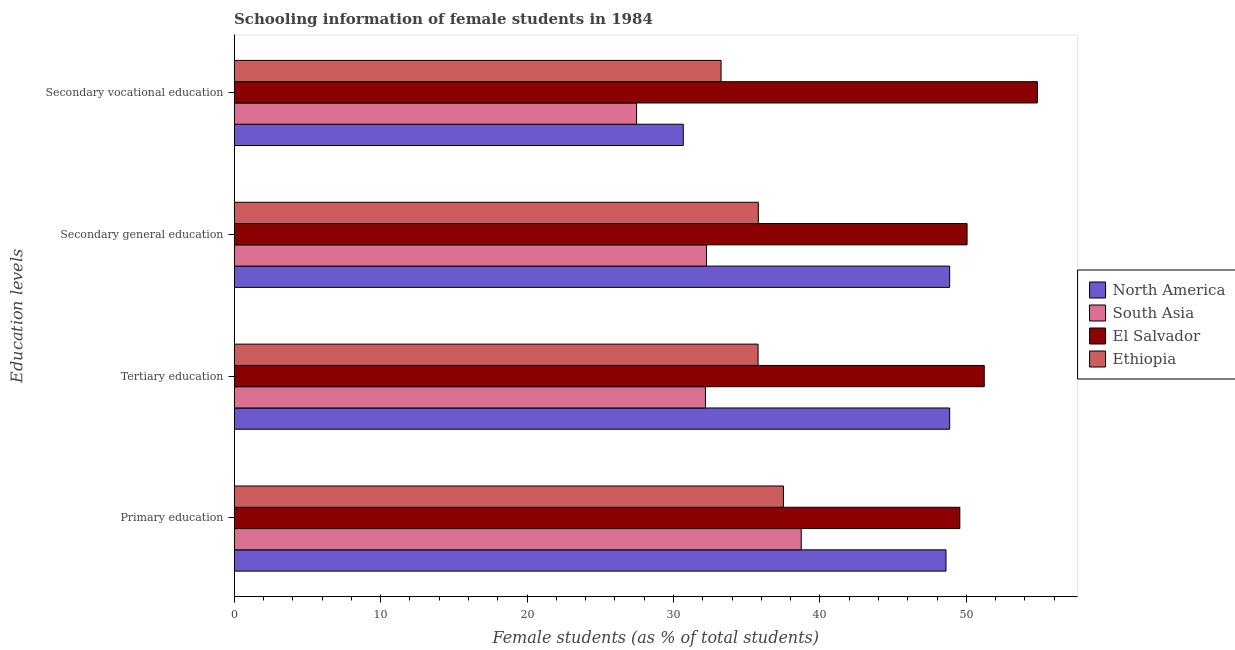How many different coloured bars are there?
Provide a succinct answer. 4. How many groups of bars are there?
Keep it short and to the point. 4. Are the number of bars on each tick of the Y-axis equal?
Your answer should be very brief. Yes. How many bars are there on the 1st tick from the top?
Offer a terse response. 4. What is the label of the 1st group of bars from the top?
Offer a very short reply. Secondary vocational education. What is the percentage of female students in primary education in South Asia?
Your answer should be compact. 38.72. Across all countries, what is the maximum percentage of female students in primary education?
Offer a terse response. 49.55. Across all countries, what is the minimum percentage of female students in primary education?
Your answer should be very brief. 37.51. In which country was the percentage of female students in secondary vocational education maximum?
Your response must be concise. El Salvador. In which country was the percentage of female students in tertiary education minimum?
Make the answer very short. South Asia. What is the total percentage of female students in tertiary education in the graph?
Provide a succinct answer. 168.04. What is the difference between the percentage of female students in tertiary education in Ethiopia and that in El Salvador?
Keep it short and to the point. -15.45. What is the difference between the percentage of female students in secondary education in Ethiopia and the percentage of female students in secondary vocational education in North America?
Keep it short and to the point. 5.12. What is the average percentage of female students in secondary vocational education per country?
Your answer should be compact. 36.56. What is the difference between the percentage of female students in secondary vocational education and percentage of female students in tertiary education in Ethiopia?
Your answer should be compact. -2.53. What is the ratio of the percentage of female students in secondary vocational education in Ethiopia to that in South Asia?
Your response must be concise. 1.21. Is the percentage of female students in primary education in North America less than that in El Salvador?
Offer a terse response. Yes. Is the difference between the percentage of female students in secondary education in El Salvador and South Asia greater than the difference between the percentage of female students in tertiary education in El Salvador and South Asia?
Give a very brief answer. No. What is the difference between the highest and the second highest percentage of female students in secondary education?
Your answer should be compact. 1.19. What is the difference between the highest and the lowest percentage of female students in primary education?
Your answer should be compact. 12.05. In how many countries, is the percentage of female students in secondary education greater than the average percentage of female students in secondary education taken over all countries?
Offer a very short reply. 2. Is the sum of the percentage of female students in secondary vocational education in North America and Ethiopia greater than the maximum percentage of female students in secondary education across all countries?
Provide a succinct answer. Yes. Is it the case that in every country, the sum of the percentage of female students in secondary vocational education and percentage of female students in secondary education is greater than the sum of percentage of female students in primary education and percentage of female students in tertiary education?
Provide a succinct answer. No. What does the 2nd bar from the bottom in Primary education represents?
Make the answer very short. South Asia. How many bars are there?
Offer a very short reply. 16. Are all the bars in the graph horizontal?
Provide a short and direct response. Yes. Does the graph contain grids?
Your response must be concise. No. Where does the legend appear in the graph?
Offer a terse response. Center right. How many legend labels are there?
Keep it short and to the point. 4. What is the title of the graph?
Give a very brief answer. Schooling information of female students in 1984. Does "Ireland" appear as one of the legend labels in the graph?
Your answer should be compact. No. What is the label or title of the X-axis?
Offer a terse response. Female students (as % of total students). What is the label or title of the Y-axis?
Give a very brief answer. Education levels. What is the Female students (as % of total students) in North America in Primary education?
Offer a very short reply. 48.61. What is the Female students (as % of total students) in South Asia in Primary education?
Make the answer very short. 38.72. What is the Female students (as % of total students) in El Salvador in Primary education?
Give a very brief answer. 49.55. What is the Female students (as % of total students) in Ethiopia in Primary education?
Your answer should be compact. 37.51. What is the Female students (as % of total students) of North America in Tertiary education?
Give a very brief answer. 48.86. What is the Female students (as % of total students) of South Asia in Tertiary education?
Provide a succinct answer. 32.18. What is the Female students (as % of total students) of El Salvador in Tertiary education?
Give a very brief answer. 51.22. What is the Female students (as % of total students) in Ethiopia in Tertiary education?
Ensure brevity in your answer.  35.78. What is the Female students (as % of total students) of North America in Secondary general education?
Provide a succinct answer. 48.86. What is the Female students (as % of total students) of South Asia in Secondary general education?
Provide a succinct answer. 32.25. What is the Female students (as % of total students) in El Salvador in Secondary general education?
Ensure brevity in your answer.  50.05. What is the Female students (as % of total students) in Ethiopia in Secondary general education?
Your answer should be very brief. 35.79. What is the Female students (as % of total students) in North America in Secondary vocational education?
Give a very brief answer. 30.67. What is the Female students (as % of total students) in South Asia in Secondary vocational education?
Your answer should be very brief. 27.48. What is the Female students (as % of total students) of El Salvador in Secondary vocational education?
Make the answer very short. 54.85. What is the Female students (as % of total students) of Ethiopia in Secondary vocational education?
Make the answer very short. 33.25. Across all Education levels, what is the maximum Female students (as % of total students) of North America?
Your response must be concise. 48.86. Across all Education levels, what is the maximum Female students (as % of total students) of South Asia?
Keep it short and to the point. 38.72. Across all Education levels, what is the maximum Female students (as % of total students) of El Salvador?
Ensure brevity in your answer.  54.85. Across all Education levels, what is the maximum Female students (as % of total students) in Ethiopia?
Your answer should be very brief. 37.51. Across all Education levels, what is the minimum Female students (as % of total students) of North America?
Make the answer very short. 30.67. Across all Education levels, what is the minimum Female students (as % of total students) in South Asia?
Ensure brevity in your answer.  27.48. Across all Education levels, what is the minimum Female students (as % of total students) of El Salvador?
Keep it short and to the point. 49.55. Across all Education levels, what is the minimum Female students (as % of total students) in Ethiopia?
Offer a very short reply. 33.25. What is the total Female students (as % of total students) of North America in the graph?
Your answer should be very brief. 176.99. What is the total Female students (as % of total students) of South Asia in the graph?
Offer a terse response. 130.64. What is the total Female students (as % of total students) in El Salvador in the graph?
Keep it short and to the point. 205.67. What is the total Female students (as % of total students) of Ethiopia in the graph?
Ensure brevity in your answer.  142.33. What is the difference between the Female students (as % of total students) in North America in Primary education and that in Tertiary education?
Your response must be concise. -0.25. What is the difference between the Female students (as % of total students) in South Asia in Primary education and that in Tertiary education?
Ensure brevity in your answer.  6.54. What is the difference between the Female students (as % of total students) in El Salvador in Primary education and that in Tertiary education?
Ensure brevity in your answer.  -1.67. What is the difference between the Female students (as % of total students) of Ethiopia in Primary education and that in Tertiary education?
Your response must be concise. 1.73. What is the difference between the Female students (as % of total students) of North America in Primary education and that in Secondary general education?
Make the answer very short. -0.25. What is the difference between the Female students (as % of total students) of South Asia in Primary education and that in Secondary general education?
Give a very brief answer. 6.47. What is the difference between the Female students (as % of total students) in El Salvador in Primary education and that in Secondary general education?
Your answer should be very brief. -0.49. What is the difference between the Female students (as % of total students) in Ethiopia in Primary education and that in Secondary general education?
Keep it short and to the point. 1.71. What is the difference between the Female students (as % of total students) in North America in Primary education and that in Secondary vocational education?
Make the answer very short. 17.94. What is the difference between the Female students (as % of total students) of South Asia in Primary education and that in Secondary vocational education?
Offer a terse response. 11.24. What is the difference between the Female students (as % of total students) in El Salvador in Primary education and that in Secondary vocational education?
Your answer should be compact. -5.3. What is the difference between the Female students (as % of total students) in Ethiopia in Primary education and that in Secondary vocational education?
Make the answer very short. 4.26. What is the difference between the Female students (as % of total students) in North America in Tertiary education and that in Secondary general education?
Keep it short and to the point. -0. What is the difference between the Female students (as % of total students) of South Asia in Tertiary education and that in Secondary general education?
Make the answer very short. -0.07. What is the difference between the Female students (as % of total students) of El Salvador in Tertiary education and that in Secondary general education?
Offer a terse response. 1.17. What is the difference between the Female students (as % of total students) in Ethiopia in Tertiary education and that in Secondary general education?
Your answer should be compact. -0.02. What is the difference between the Female students (as % of total students) in North America in Tertiary education and that in Secondary vocational education?
Provide a succinct answer. 18.19. What is the difference between the Female students (as % of total students) of South Asia in Tertiary education and that in Secondary vocational education?
Provide a succinct answer. 4.7. What is the difference between the Female students (as % of total students) in El Salvador in Tertiary education and that in Secondary vocational education?
Make the answer very short. -3.63. What is the difference between the Female students (as % of total students) of Ethiopia in Tertiary education and that in Secondary vocational education?
Your answer should be very brief. 2.53. What is the difference between the Female students (as % of total students) in North America in Secondary general education and that in Secondary vocational education?
Ensure brevity in your answer.  18.19. What is the difference between the Female students (as % of total students) of South Asia in Secondary general education and that in Secondary vocational education?
Make the answer very short. 4.77. What is the difference between the Female students (as % of total students) in El Salvador in Secondary general education and that in Secondary vocational education?
Offer a very short reply. -4.8. What is the difference between the Female students (as % of total students) in Ethiopia in Secondary general education and that in Secondary vocational education?
Your answer should be very brief. 2.54. What is the difference between the Female students (as % of total students) of North America in Primary education and the Female students (as % of total students) of South Asia in Tertiary education?
Offer a terse response. 16.42. What is the difference between the Female students (as % of total students) in North America in Primary education and the Female students (as % of total students) in El Salvador in Tertiary education?
Your response must be concise. -2.62. What is the difference between the Female students (as % of total students) of North America in Primary education and the Female students (as % of total students) of Ethiopia in Tertiary education?
Ensure brevity in your answer.  12.83. What is the difference between the Female students (as % of total students) of South Asia in Primary education and the Female students (as % of total students) of El Salvador in Tertiary education?
Offer a terse response. -12.5. What is the difference between the Female students (as % of total students) in South Asia in Primary education and the Female students (as % of total students) in Ethiopia in Tertiary education?
Your response must be concise. 2.95. What is the difference between the Female students (as % of total students) of El Salvador in Primary education and the Female students (as % of total students) of Ethiopia in Tertiary education?
Make the answer very short. 13.78. What is the difference between the Female students (as % of total students) of North America in Primary education and the Female students (as % of total students) of South Asia in Secondary general education?
Your answer should be compact. 16.35. What is the difference between the Female students (as % of total students) in North America in Primary education and the Female students (as % of total students) in El Salvador in Secondary general education?
Make the answer very short. -1.44. What is the difference between the Female students (as % of total students) of North America in Primary education and the Female students (as % of total students) of Ethiopia in Secondary general education?
Your answer should be compact. 12.81. What is the difference between the Female students (as % of total students) of South Asia in Primary education and the Female students (as % of total students) of El Salvador in Secondary general education?
Make the answer very short. -11.32. What is the difference between the Female students (as % of total students) of South Asia in Primary education and the Female students (as % of total students) of Ethiopia in Secondary general education?
Keep it short and to the point. 2.93. What is the difference between the Female students (as % of total students) in El Salvador in Primary education and the Female students (as % of total students) in Ethiopia in Secondary general education?
Your answer should be very brief. 13.76. What is the difference between the Female students (as % of total students) of North America in Primary education and the Female students (as % of total students) of South Asia in Secondary vocational education?
Ensure brevity in your answer.  21.13. What is the difference between the Female students (as % of total students) in North America in Primary education and the Female students (as % of total students) in El Salvador in Secondary vocational education?
Your response must be concise. -6.24. What is the difference between the Female students (as % of total students) of North America in Primary education and the Female students (as % of total students) of Ethiopia in Secondary vocational education?
Ensure brevity in your answer.  15.36. What is the difference between the Female students (as % of total students) of South Asia in Primary education and the Female students (as % of total students) of El Salvador in Secondary vocational education?
Give a very brief answer. -16.12. What is the difference between the Female students (as % of total students) in South Asia in Primary education and the Female students (as % of total students) in Ethiopia in Secondary vocational education?
Ensure brevity in your answer.  5.47. What is the difference between the Female students (as % of total students) of El Salvador in Primary education and the Female students (as % of total students) of Ethiopia in Secondary vocational education?
Your response must be concise. 16.3. What is the difference between the Female students (as % of total students) in North America in Tertiary education and the Female students (as % of total students) in South Asia in Secondary general education?
Offer a very short reply. 16.61. What is the difference between the Female students (as % of total students) in North America in Tertiary education and the Female students (as % of total students) in El Salvador in Secondary general education?
Your answer should be compact. -1.19. What is the difference between the Female students (as % of total students) in North America in Tertiary education and the Female students (as % of total students) in Ethiopia in Secondary general education?
Ensure brevity in your answer.  13.07. What is the difference between the Female students (as % of total students) of South Asia in Tertiary education and the Female students (as % of total students) of El Salvador in Secondary general education?
Keep it short and to the point. -17.86. What is the difference between the Female students (as % of total students) in South Asia in Tertiary education and the Female students (as % of total students) in Ethiopia in Secondary general education?
Your answer should be very brief. -3.61. What is the difference between the Female students (as % of total students) in El Salvador in Tertiary education and the Female students (as % of total students) in Ethiopia in Secondary general education?
Keep it short and to the point. 15.43. What is the difference between the Female students (as % of total students) in North America in Tertiary education and the Female students (as % of total students) in South Asia in Secondary vocational education?
Offer a terse response. 21.38. What is the difference between the Female students (as % of total students) of North America in Tertiary education and the Female students (as % of total students) of El Salvador in Secondary vocational education?
Your answer should be compact. -5.99. What is the difference between the Female students (as % of total students) in North America in Tertiary education and the Female students (as % of total students) in Ethiopia in Secondary vocational education?
Give a very brief answer. 15.61. What is the difference between the Female students (as % of total students) of South Asia in Tertiary education and the Female students (as % of total students) of El Salvador in Secondary vocational education?
Make the answer very short. -22.67. What is the difference between the Female students (as % of total students) in South Asia in Tertiary education and the Female students (as % of total students) in Ethiopia in Secondary vocational education?
Offer a terse response. -1.07. What is the difference between the Female students (as % of total students) of El Salvador in Tertiary education and the Female students (as % of total students) of Ethiopia in Secondary vocational education?
Your answer should be compact. 17.97. What is the difference between the Female students (as % of total students) of North America in Secondary general education and the Female students (as % of total students) of South Asia in Secondary vocational education?
Keep it short and to the point. 21.38. What is the difference between the Female students (as % of total students) in North America in Secondary general education and the Female students (as % of total students) in El Salvador in Secondary vocational education?
Provide a short and direct response. -5.99. What is the difference between the Female students (as % of total students) in North America in Secondary general education and the Female students (as % of total students) in Ethiopia in Secondary vocational education?
Offer a terse response. 15.61. What is the difference between the Female students (as % of total students) of South Asia in Secondary general education and the Female students (as % of total students) of El Salvador in Secondary vocational education?
Provide a succinct answer. -22.6. What is the difference between the Female students (as % of total students) in South Asia in Secondary general education and the Female students (as % of total students) in Ethiopia in Secondary vocational education?
Give a very brief answer. -1. What is the difference between the Female students (as % of total students) in El Salvador in Secondary general education and the Female students (as % of total students) in Ethiopia in Secondary vocational education?
Offer a very short reply. 16.8. What is the average Female students (as % of total students) in North America per Education levels?
Ensure brevity in your answer.  44.25. What is the average Female students (as % of total students) of South Asia per Education levels?
Your response must be concise. 32.66. What is the average Female students (as % of total students) in El Salvador per Education levels?
Ensure brevity in your answer.  51.42. What is the average Female students (as % of total students) in Ethiopia per Education levels?
Ensure brevity in your answer.  35.58. What is the difference between the Female students (as % of total students) of North America and Female students (as % of total students) of South Asia in Primary education?
Make the answer very short. 9.88. What is the difference between the Female students (as % of total students) in North America and Female students (as % of total students) in El Salvador in Primary education?
Ensure brevity in your answer.  -0.95. What is the difference between the Female students (as % of total students) in North America and Female students (as % of total students) in Ethiopia in Primary education?
Your answer should be very brief. 11.1. What is the difference between the Female students (as % of total students) in South Asia and Female students (as % of total students) in El Salvador in Primary education?
Your answer should be compact. -10.83. What is the difference between the Female students (as % of total students) in South Asia and Female students (as % of total students) in Ethiopia in Primary education?
Your answer should be very brief. 1.22. What is the difference between the Female students (as % of total students) of El Salvador and Female students (as % of total students) of Ethiopia in Primary education?
Your answer should be compact. 12.05. What is the difference between the Female students (as % of total students) in North America and Female students (as % of total students) in South Asia in Tertiary education?
Offer a terse response. 16.68. What is the difference between the Female students (as % of total students) in North America and Female students (as % of total students) in El Salvador in Tertiary education?
Provide a succinct answer. -2.36. What is the difference between the Female students (as % of total students) of North America and Female students (as % of total students) of Ethiopia in Tertiary education?
Offer a terse response. 13.08. What is the difference between the Female students (as % of total students) of South Asia and Female students (as % of total students) of El Salvador in Tertiary education?
Your response must be concise. -19.04. What is the difference between the Female students (as % of total students) of South Asia and Female students (as % of total students) of Ethiopia in Tertiary education?
Your answer should be very brief. -3.59. What is the difference between the Female students (as % of total students) of El Salvador and Female students (as % of total students) of Ethiopia in Tertiary education?
Provide a short and direct response. 15.45. What is the difference between the Female students (as % of total students) in North America and Female students (as % of total students) in South Asia in Secondary general education?
Ensure brevity in your answer.  16.61. What is the difference between the Female students (as % of total students) in North America and Female students (as % of total students) in El Salvador in Secondary general education?
Make the answer very short. -1.19. What is the difference between the Female students (as % of total students) in North America and Female students (as % of total students) in Ethiopia in Secondary general education?
Ensure brevity in your answer.  13.07. What is the difference between the Female students (as % of total students) in South Asia and Female students (as % of total students) in El Salvador in Secondary general education?
Your answer should be compact. -17.79. What is the difference between the Female students (as % of total students) of South Asia and Female students (as % of total students) of Ethiopia in Secondary general education?
Ensure brevity in your answer.  -3.54. What is the difference between the Female students (as % of total students) in El Salvador and Female students (as % of total students) in Ethiopia in Secondary general education?
Keep it short and to the point. 14.25. What is the difference between the Female students (as % of total students) of North America and Female students (as % of total students) of South Asia in Secondary vocational education?
Your response must be concise. 3.19. What is the difference between the Female students (as % of total students) of North America and Female students (as % of total students) of El Salvador in Secondary vocational education?
Provide a short and direct response. -24.18. What is the difference between the Female students (as % of total students) in North America and Female students (as % of total students) in Ethiopia in Secondary vocational education?
Ensure brevity in your answer.  -2.58. What is the difference between the Female students (as % of total students) in South Asia and Female students (as % of total students) in El Salvador in Secondary vocational education?
Your response must be concise. -27.37. What is the difference between the Female students (as % of total students) of South Asia and Female students (as % of total students) of Ethiopia in Secondary vocational education?
Your answer should be very brief. -5.77. What is the difference between the Female students (as % of total students) in El Salvador and Female students (as % of total students) in Ethiopia in Secondary vocational education?
Your response must be concise. 21.6. What is the ratio of the Female students (as % of total students) in South Asia in Primary education to that in Tertiary education?
Ensure brevity in your answer.  1.2. What is the ratio of the Female students (as % of total students) in El Salvador in Primary education to that in Tertiary education?
Provide a short and direct response. 0.97. What is the ratio of the Female students (as % of total students) of Ethiopia in Primary education to that in Tertiary education?
Make the answer very short. 1.05. What is the ratio of the Female students (as % of total students) in North America in Primary education to that in Secondary general education?
Your answer should be very brief. 0.99. What is the ratio of the Female students (as % of total students) of South Asia in Primary education to that in Secondary general education?
Provide a succinct answer. 1.2. What is the ratio of the Female students (as % of total students) of El Salvador in Primary education to that in Secondary general education?
Offer a terse response. 0.99. What is the ratio of the Female students (as % of total students) of Ethiopia in Primary education to that in Secondary general education?
Ensure brevity in your answer.  1.05. What is the ratio of the Female students (as % of total students) in North America in Primary education to that in Secondary vocational education?
Your answer should be very brief. 1.58. What is the ratio of the Female students (as % of total students) in South Asia in Primary education to that in Secondary vocational education?
Offer a terse response. 1.41. What is the ratio of the Female students (as % of total students) of El Salvador in Primary education to that in Secondary vocational education?
Provide a short and direct response. 0.9. What is the ratio of the Female students (as % of total students) of Ethiopia in Primary education to that in Secondary vocational education?
Ensure brevity in your answer.  1.13. What is the ratio of the Female students (as % of total students) of El Salvador in Tertiary education to that in Secondary general education?
Provide a succinct answer. 1.02. What is the ratio of the Female students (as % of total students) of Ethiopia in Tertiary education to that in Secondary general education?
Provide a succinct answer. 1. What is the ratio of the Female students (as % of total students) in North America in Tertiary education to that in Secondary vocational education?
Your answer should be compact. 1.59. What is the ratio of the Female students (as % of total students) in South Asia in Tertiary education to that in Secondary vocational education?
Give a very brief answer. 1.17. What is the ratio of the Female students (as % of total students) in El Salvador in Tertiary education to that in Secondary vocational education?
Your answer should be very brief. 0.93. What is the ratio of the Female students (as % of total students) of Ethiopia in Tertiary education to that in Secondary vocational education?
Keep it short and to the point. 1.08. What is the ratio of the Female students (as % of total students) in North America in Secondary general education to that in Secondary vocational education?
Provide a succinct answer. 1.59. What is the ratio of the Female students (as % of total students) of South Asia in Secondary general education to that in Secondary vocational education?
Offer a terse response. 1.17. What is the ratio of the Female students (as % of total students) of El Salvador in Secondary general education to that in Secondary vocational education?
Ensure brevity in your answer.  0.91. What is the ratio of the Female students (as % of total students) of Ethiopia in Secondary general education to that in Secondary vocational education?
Keep it short and to the point. 1.08. What is the difference between the highest and the second highest Female students (as % of total students) in South Asia?
Ensure brevity in your answer.  6.47. What is the difference between the highest and the second highest Female students (as % of total students) of El Salvador?
Keep it short and to the point. 3.63. What is the difference between the highest and the second highest Female students (as % of total students) of Ethiopia?
Offer a very short reply. 1.71. What is the difference between the highest and the lowest Female students (as % of total students) in North America?
Your answer should be very brief. 18.19. What is the difference between the highest and the lowest Female students (as % of total students) of South Asia?
Keep it short and to the point. 11.24. What is the difference between the highest and the lowest Female students (as % of total students) in El Salvador?
Your answer should be very brief. 5.3. What is the difference between the highest and the lowest Female students (as % of total students) in Ethiopia?
Provide a succinct answer. 4.26. 